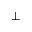<formula> <loc_0><loc_0><loc_500><loc_500>\bot</formula> 